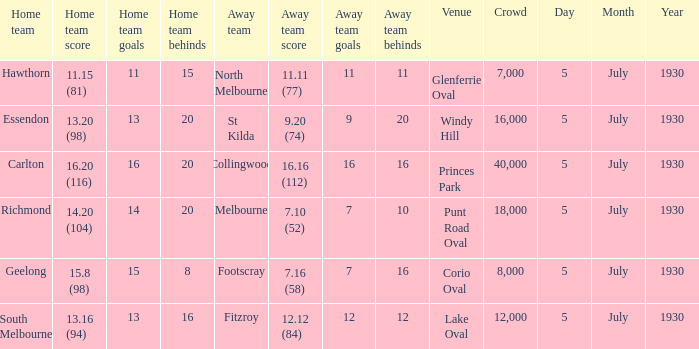What is the place when fitzroy participated as the guest team? Lake Oval. 